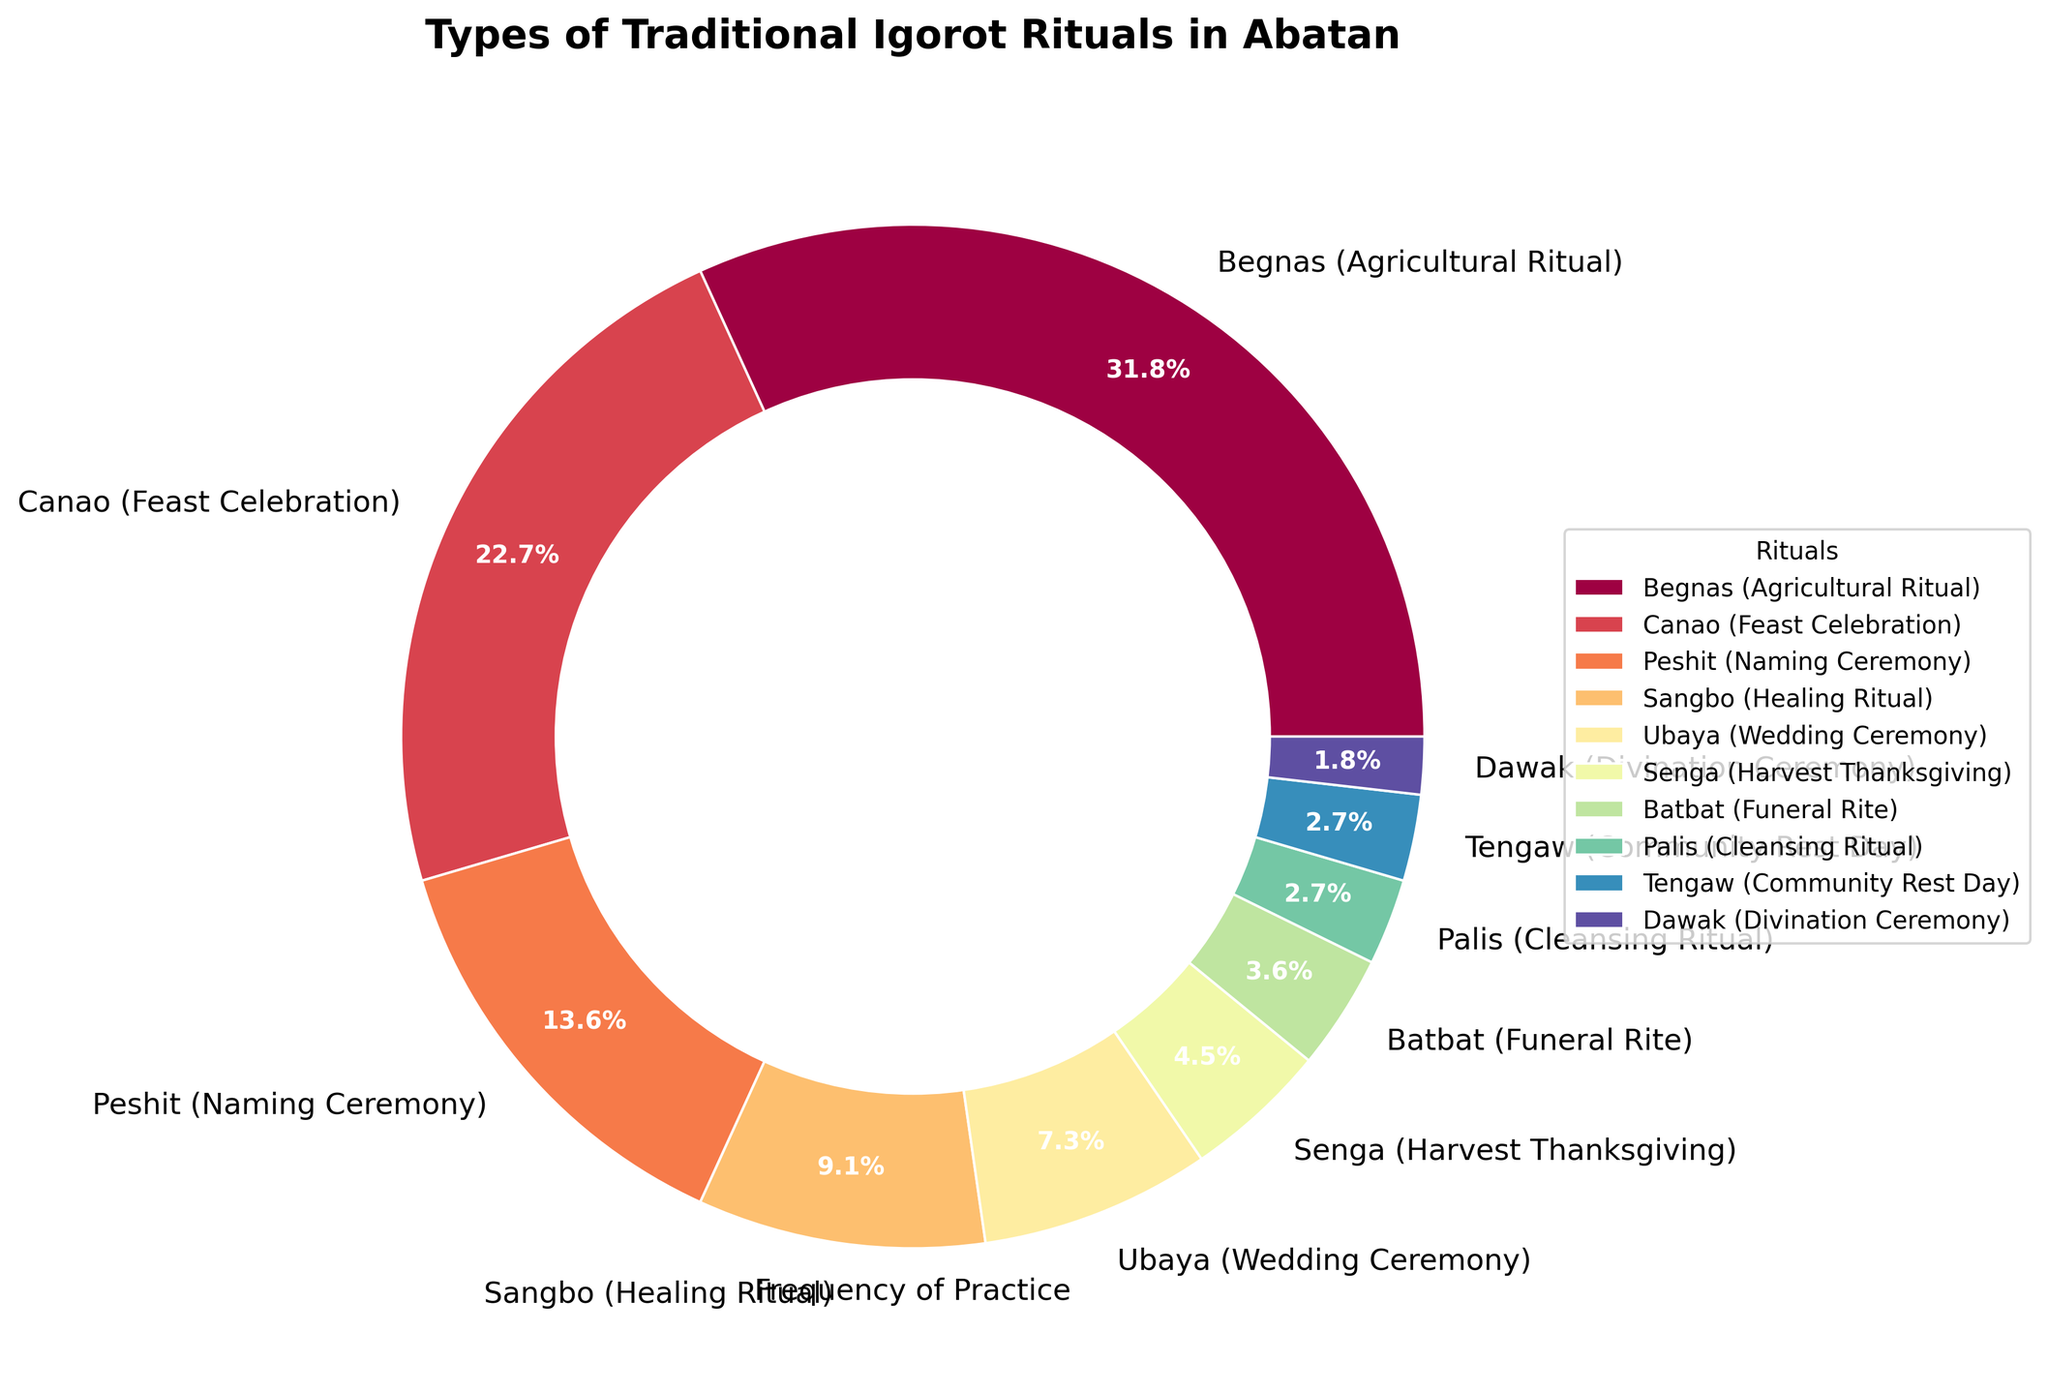Which ritual is practiced most frequently? The pie chart clearly shows the size of each segment representing the frequency of each ritual. The largest segment corresponds to Begnas (Agricultural Ritual).
Answer: Begnas (Agricultural Ritual) How many more times is the Canao (Feast Celebration) performed than the Batbat (Funeral Rite)? The frequency of the Canao (Feast Celebration) is 25 and the frequency of the Batbat (Funeral Rite) is 4. The difference is calculated by subtracting the smaller from the larger frequency: 25 - 4.
Answer: 21 Which rituals have the least frequency, and are their frequencies equal? The smallest segments in the pie chart are for Dawak (Divination Ceremony) and Palis (Cleansing Ritual) with three and two being the lowest. A quick look at their sizes shows they are not equal, the Dawak (Divination Ceremony) segment is slightly smaller.
Answer: Dawak (Divination Ceremony) and Palis (Cleansing Ritual), not equal What percentage of the rituals are Begnas (Agricultural Ritual) or Canao (Feast Celebration)? To find the percentage, sum the frequencies of Begnas and Canao and then divide by the total frequency and multiply by 100. The total frequency is 35 (Begnas) + 25 (Canao) = 60. The overall total is the sum of all frequencies: 35 + 25 + 15 + 10 + 8 + 5 + 4 + 3 + 3 + 2 = 110. Thus, the percentage is (60 / 110) * 100.
Answer: 54.5% Are there more rituals related to celebrations (Begnas, Canao, Ubaya) or to healing and cleansing (Sangbo, Palis)? Sum the frequencies of migration and country of birth (Begnas 35 + Canao 25 + Ubaya 8= 68) and the frequencies of healing and cleansing rituals (Sangbo 10 + Palis 3= 13). Comparatively, celebrations have a higher frequency.
Answer: Celebrations (68 vs. 13) What is the difference in frequency between Peshit (Naming Ceremony) and Sangbo (Healing Ritual)? The frequency of Peshit (Naming Ceremony) is 15 and Sangbo (Healing Ritual) is 10. The difference is calculated by subtracting the smaller frequency from the larger: 15 - 10.
Answer: 5 Which ritual is represented by the green color in the pie chart? The green color is associated with the medium-sized segment in the pie chart when looking at the distribution of colors. By selecting and matching the color to the legend, Ubaya (Wedding Ceremony) matches the green color.
Answer: Ubaya (Wedding Ceremony) Is the combined frequency of rituals with frequencies less than 10 greater than that of the Canao (Feast Celebration)? Add the frequencies of rituals with frequencies less than 10: Sangbo 10, Ubaya 8, Senga 5, Batbat 4, Palis 3, Tengaw 3, Dawak 2 = 35. This sum (35) is greater than the frequency of Canao (Feast Celebration), which is 25.
Answer: Yes 